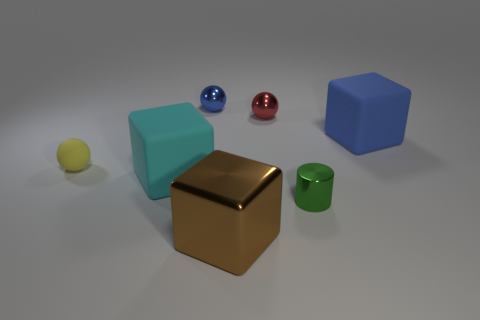Are there any cyan rubber blocks of the same size as the green cylinder?
Provide a short and direct response. No. How many large objects are both on the right side of the small red thing and to the left of the small green shiny cylinder?
Your response must be concise. 0. What number of blue balls are behind the tiny red sphere?
Your answer should be compact. 1. Are there any other small objects that have the same shape as the small red metal object?
Your answer should be very brief. Yes. There is a cyan matte object; is its shape the same as the object on the left side of the big cyan cube?
Your answer should be compact. No. What number of cylinders are tiny red metal objects or tiny green objects?
Keep it short and to the point. 1. There is a small shiny object that is on the left side of the brown cube; what shape is it?
Your answer should be compact. Sphere. What number of brown blocks are made of the same material as the brown object?
Make the answer very short. 0. Are there fewer brown shiny cubes on the right side of the small green thing than big cyan metallic objects?
Ensure brevity in your answer.  No. What size is the matte cube that is behind the yellow rubber thing in front of the red thing?
Ensure brevity in your answer.  Large. 